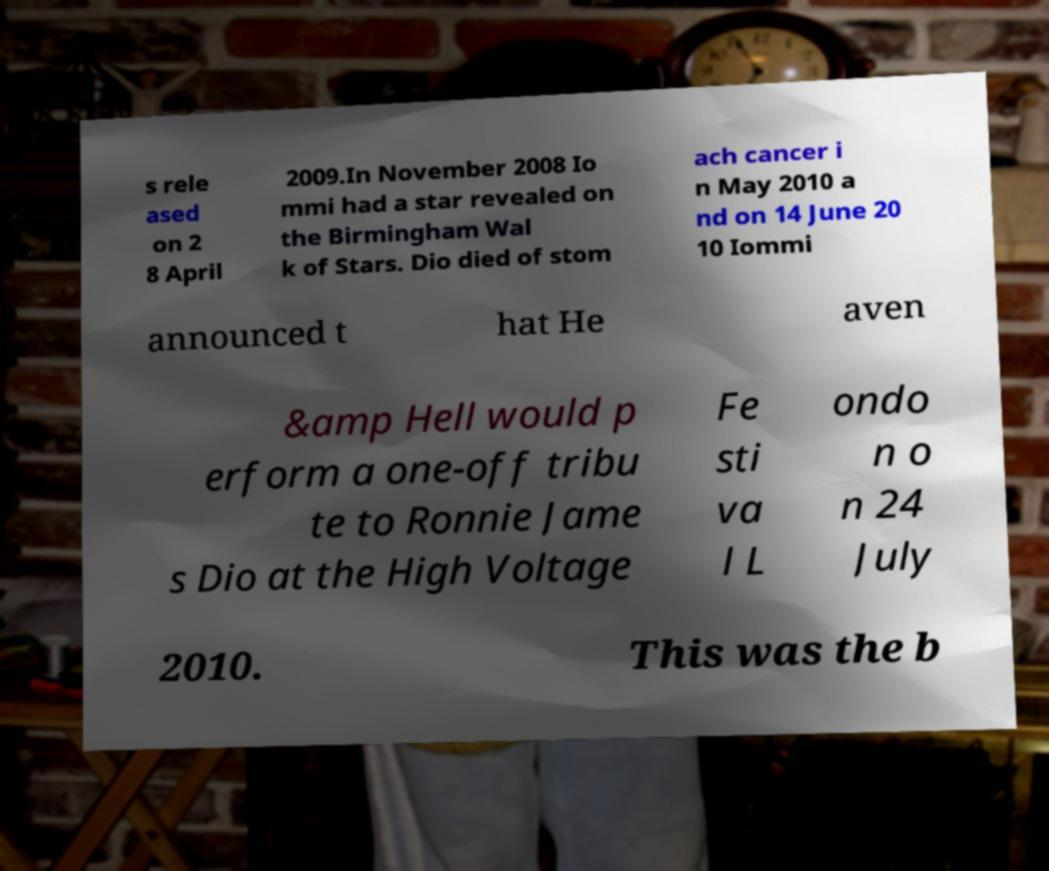Please identify and transcribe the text found in this image. s rele ased on 2 8 April 2009.In November 2008 Io mmi had a star revealed on the Birmingham Wal k of Stars. Dio died of stom ach cancer i n May 2010 a nd on 14 June 20 10 Iommi announced t hat He aven &amp Hell would p erform a one-off tribu te to Ronnie Jame s Dio at the High Voltage Fe sti va l L ondo n o n 24 July 2010. This was the b 